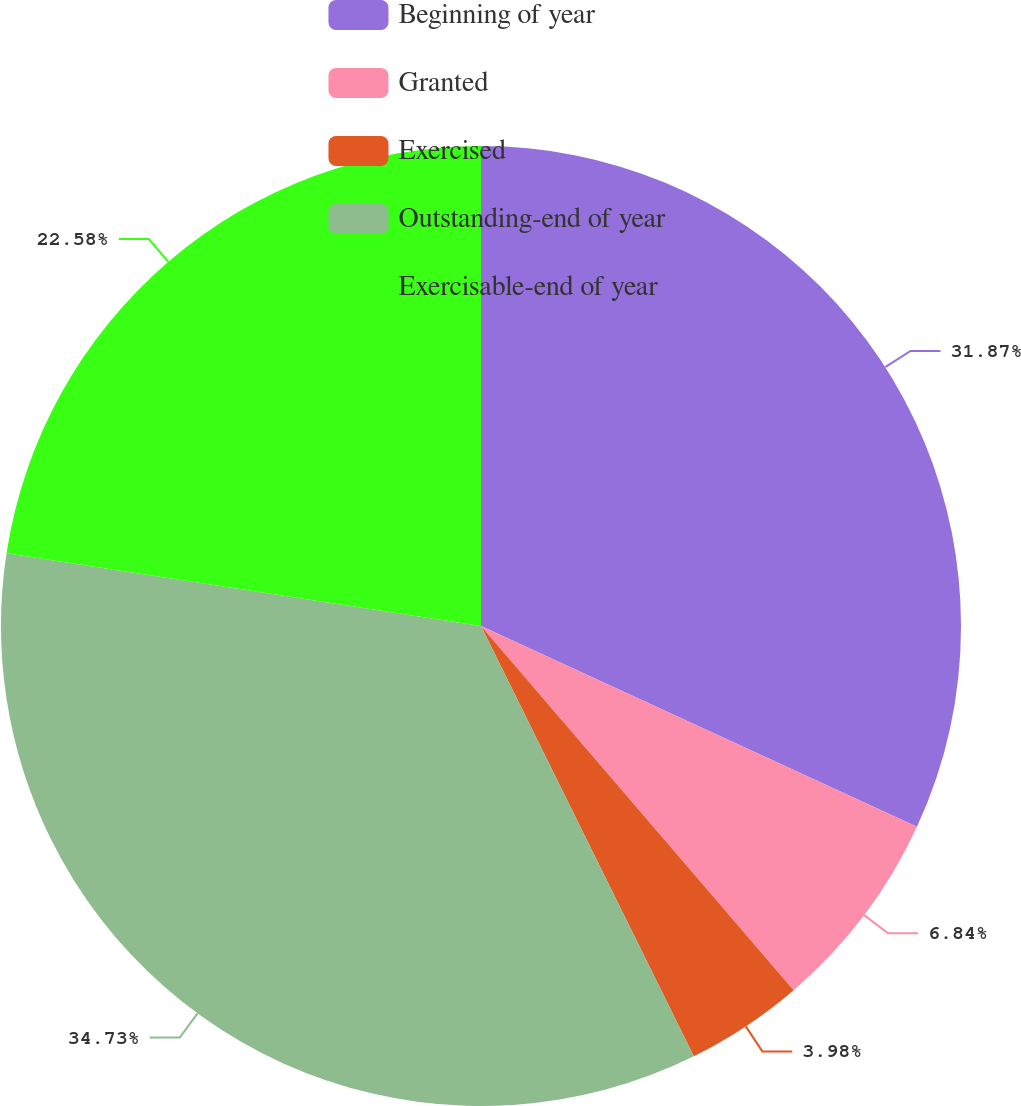Convert chart. <chart><loc_0><loc_0><loc_500><loc_500><pie_chart><fcel>Beginning of year<fcel>Granted<fcel>Exercised<fcel>Outstanding-end of year<fcel>Exercisable-end of year<nl><fcel>31.87%<fcel>6.84%<fcel>3.98%<fcel>34.73%<fcel>22.58%<nl></chart> 